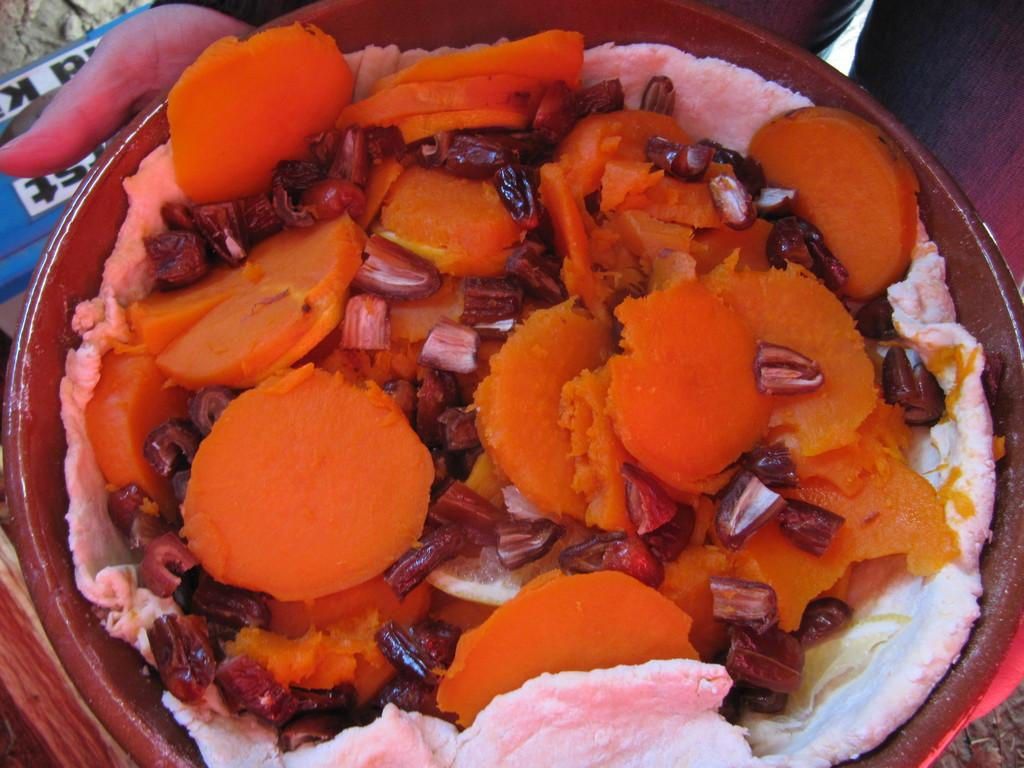What is the person in the image holding? The person is holding a bowl in the image. What is inside the bowl? The bowl contains food, including carrots, dates, and a white-colored item. Can you describe the food in the bowl? The food includes carrots, dates, and a white-colored item, which could be a type of cheese or another ingredient. How many cattle are present in the image? There are no cattle present in the image; it features a person holding a bowl with food. What is the lowest point in the image? The concept of "low" or "high" in an image is subjective and cannot be definitively answered based on the provided facts. 